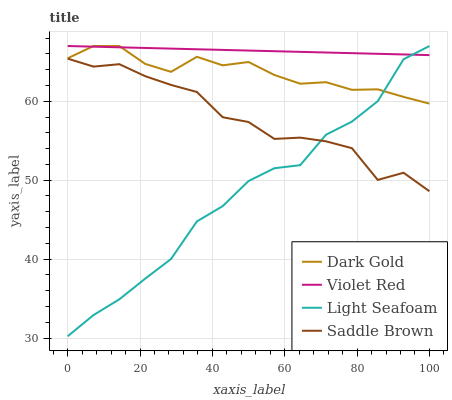Does Light Seafoam have the minimum area under the curve?
Answer yes or no. Yes. Does Violet Red have the maximum area under the curve?
Answer yes or no. Yes. Does Saddle Brown have the minimum area under the curve?
Answer yes or no. No. Does Saddle Brown have the maximum area under the curve?
Answer yes or no. No. Is Violet Red the smoothest?
Answer yes or no. Yes. Is Saddle Brown the roughest?
Answer yes or no. Yes. Is Light Seafoam the smoothest?
Answer yes or no. No. Is Light Seafoam the roughest?
Answer yes or no. No. Does Saddle Brown have the lowest value?
Answer yes or no. No. Does Dark Gold have the highest value?
Answer yes or no. Yes. Does Saddle Brown have the highest value?
Answer yes or no. No. Is Saddle Brown less than Violet Red?
Answer yes or no. Yes. Is Violet Red greater than Saddle Brown?
Answer yes or no. Yes. Does Saddle Brown intersect Violet Red?
Answer yes or no. No. 